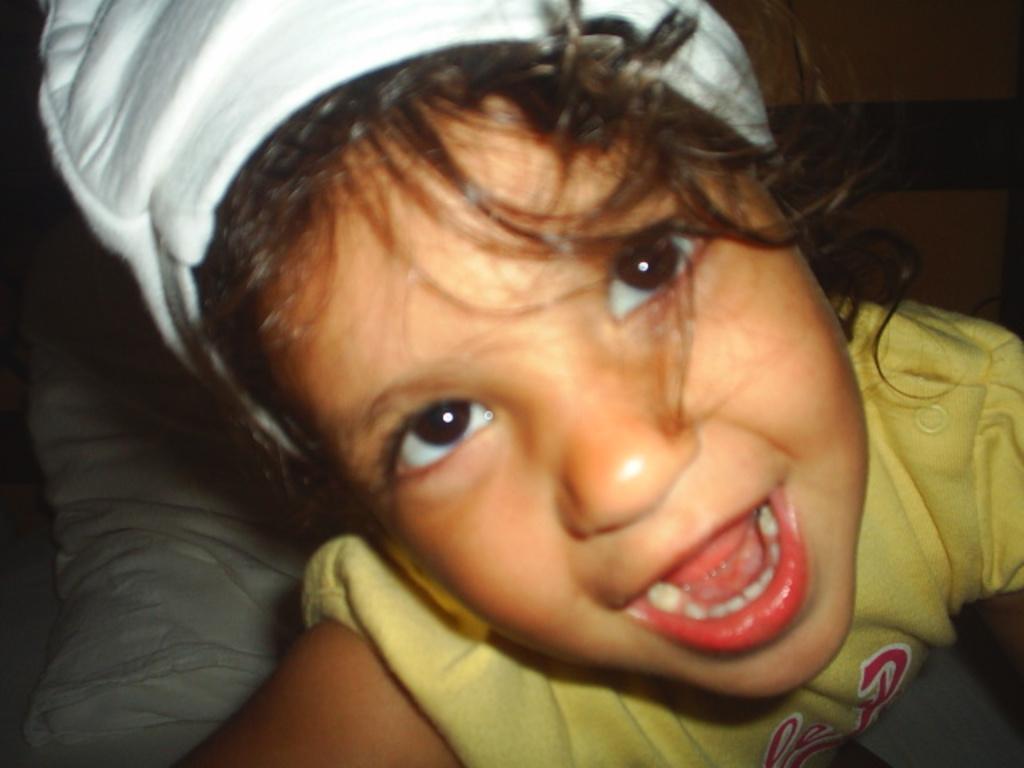In one or two sentences, can you explain what this image depicts? In this image there is a kid wearing a yellow shirt and a cap. Behind her there is a pillow. 